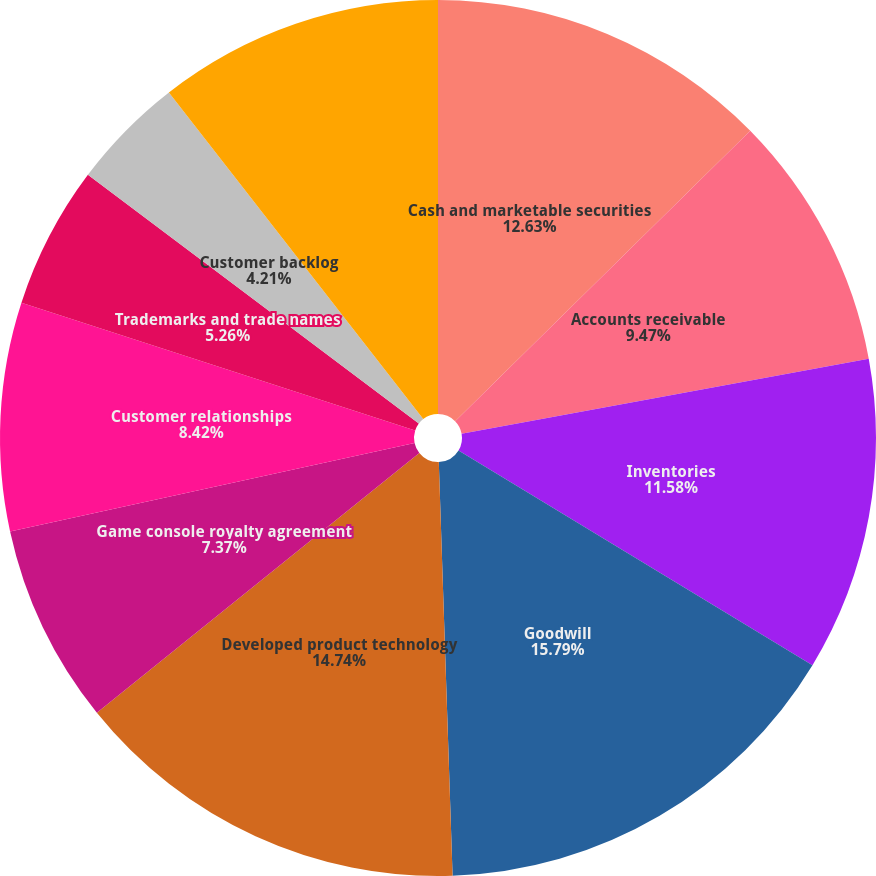Convert chart. <chart><loc_0><loc_0><loc_500><loc_500><pie_chart><fcel>Cash and marketable securities<fcel>Accounts receivable<fcel>Inventories<fcel>Goodwill<fcel>Developed product technology<fcel>Game console royalty agreement<fcel>Customer relationships<fcel>Trademarks and trade names<fcel>Customer backlog<fcel>In-process research and<nl><fcel>12.63%<fcel>9.47%<fcel>11.58%<fcel>15.79%<fcel>14.74%<fcel>7.37%<fcel>8.42%<fcel>5.26%<fcel>4.21%<fcel>10.53%<nl></chart> 